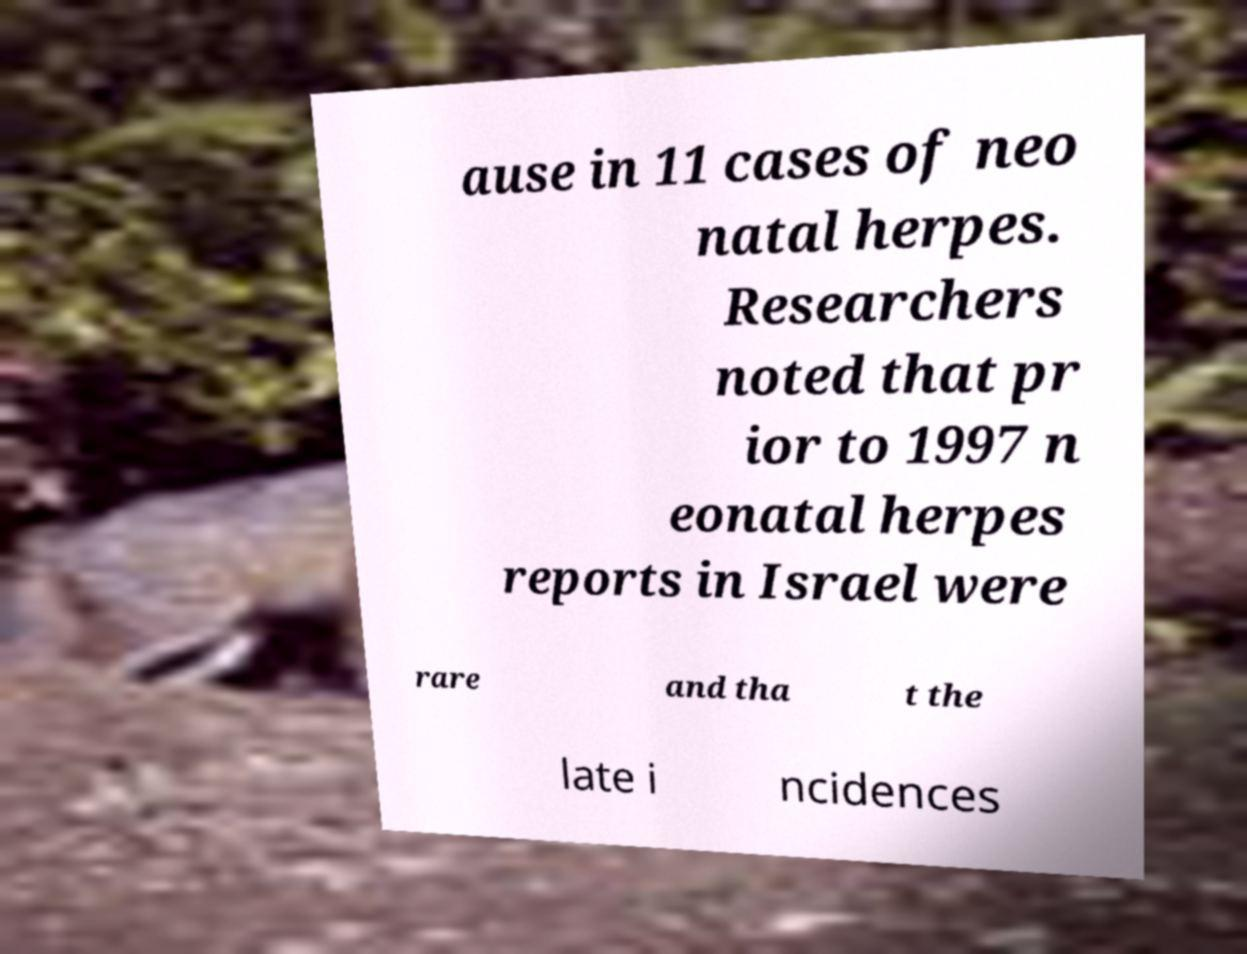There's text embedded in this image that I need extracted. Can you transcribe it verbatim? ause in 11 cases of neo natal herpes. Researchers noted that pr ior to 1997 n eonatal herpes reports in Israel were rare and tha t the late i ncidences 